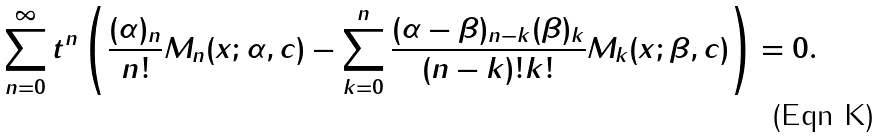<formula> <loc_0><loc_0><loc_500><loc_500>\sum _ { n = 0 } ^ { \infty } t ^ { n } \left ( \frac { ( \alpha ) _ { n } } { n ! } M _ { n } ( x ; \alpha , c ) - \sum _ { k = 0 } ^ { n } \frac { ( \alpha - \beta ) _ { n - k } ( \beta ) _ { k } } { ( n - k ) ! k ! } M _ { k } ( x ; \beta , c ) \right ) = 0 .</formula> 